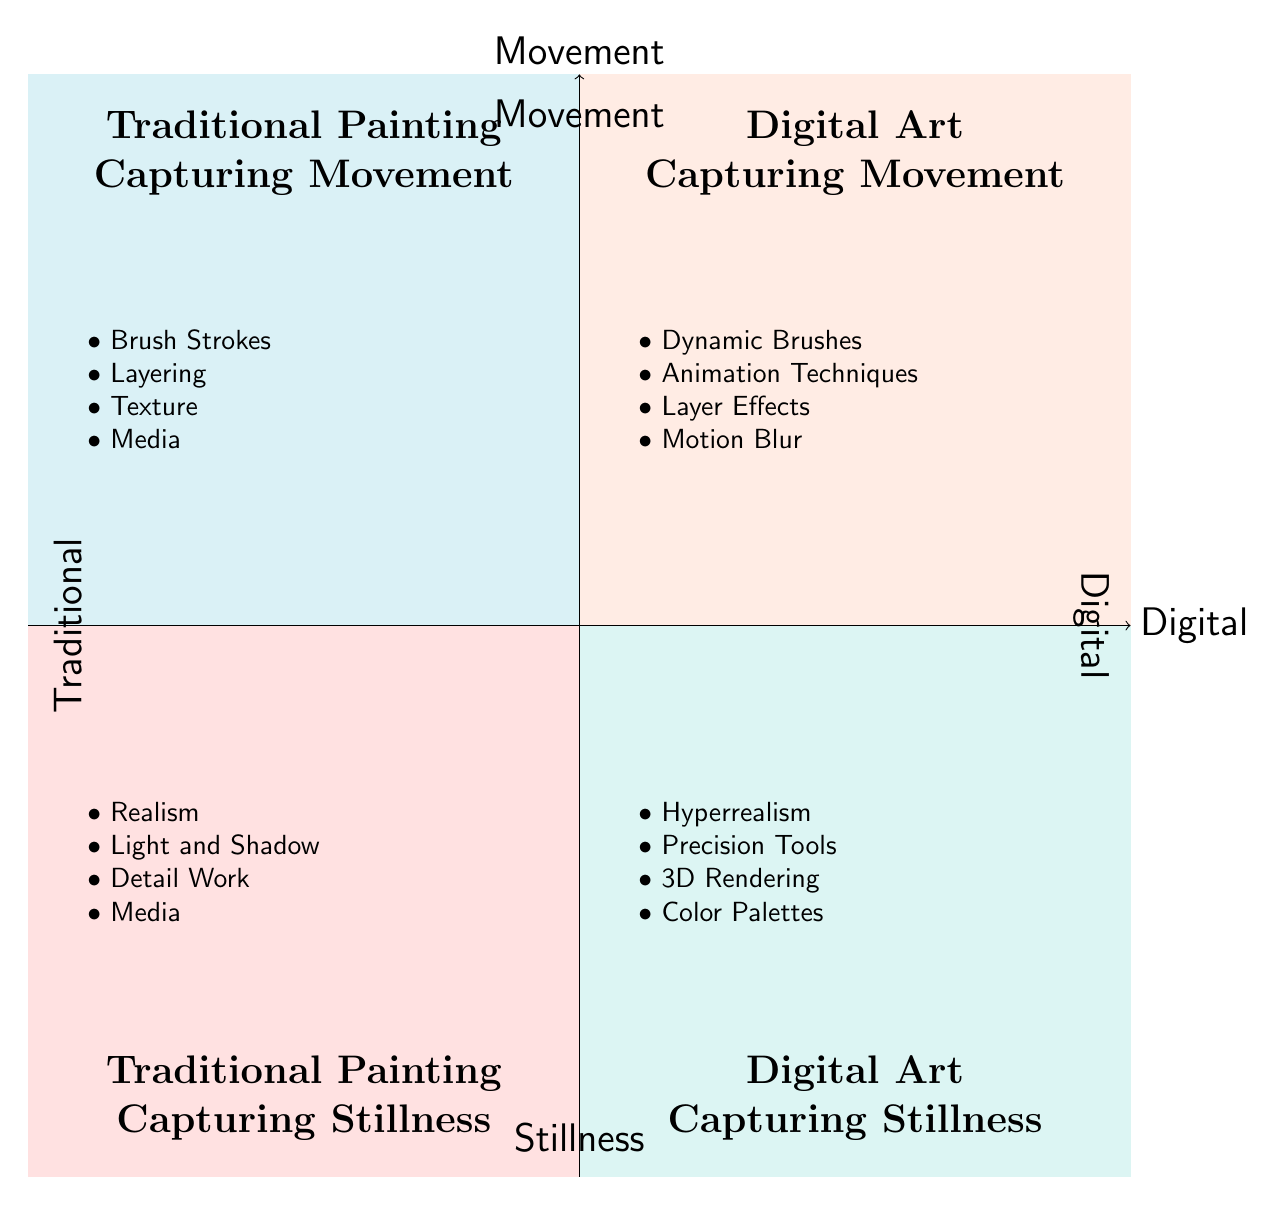What is the top-left quadrant about? The top-left quadrant is labeled "Traditional Painting - Capturing Movement", indicating it focuses on how traditional painting techniques express movement.
Answer: Traditional Painting - Capturing Movement How many elements are in the bottom-left quadrant? The bottom-left quadrant "Traditional Painting - Capturing Stillness" contains four specific elements that describe how traditional painting captures stillness.
Answer: 4 Which artistic medium employs "Animation Techniques" to capture movement? The top-right quadrant "Digital Art - Capturing Movement" features "Animation Techniques" as one of its elements, indicating that digital art utilizes this method to express movement.
Answer: Digital Art What technique is associated with artists like Vermeer in the bottom-left quadrant? The bottom-left quadrant lists "Realism" as a technique connected with artists like Vermeer, highlighting a focus on depicting tranquil, static moments.
Answer: Realism Which quadrant features "3D Rendering"? "3D Rendering" is located in the bottom-right quadrant labeled "Digital Art - Capturing Stillness", showcasing the use of digital tools for creating serene scenes.
Answer: Digital Art - Capturing Stillness How do the two top quadrants relate to each other in terms of artistic media? Both top quadrants focus on capturing movement but differentiate between traditional and digital artistic mediums, showing their unique approaches within that theme.
Answer: They both capture movement What specific technique categorizes the works of artists like Beeple? The top-right quadrant "Digital Art - Capturing Movement" identifies "Animation Techniques" as a specific method used by artists like Beeple for creating movement in digital art.
Answer: Animation Techniques Which quadrant is associated with "Light and Shadow"? The bottom-left quadrant "Traditional Painting - Capturing Stillness" is associated with "Light and Shadow", which is a technique employed to convey a sense of calm.
Answer: Traditional Painting - Capturing Stillness What media is primarily used in the bottom-right quadrant? The bottom-right quadrant discusses "Color Palettes" and mentions calm and muted color schemes, focusing on the media used for serene representations in digital art.
Answer: Digital Art - Capturing Stillness 